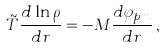<formula> <loc_0><loc_0><loc_500><loc_500>\tilde { T } \frac { d \ln \rho } { d r } = - M \frac { d \varphi _ { p m } } { d r } \, ,</formula> 